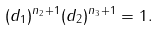Convert formula to latex. <formula><loc_0><loc_0><loc_500><loc_500>( d _ { 1 } ) ^ { n _ { 2 } + 1 } ( d _ { 2 } ) ^ { n _ { 3 } + 1 } = 1 .</formula> 